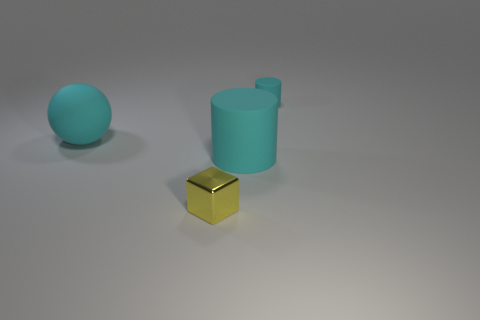Subtract all blue balls. How many green cylinders are left? 0 Add 4 big cyan things. How many big cyan things are left? 6 Add 4 big cylinders. How many big cylinders exist? 5 Add 1 cubes. How many objects exist? 5 Subtract 0 purple cubes. How many objects are left? 4 Subtract 1 cylinders. How many cylinders are left? 1 Subtract all purple cylinders. Subtract all gray balls. How many cylinders are left? 2 Subtract all large purple matte objects. Subtract all small cyan rubber cylinders. How many objects are left? 3 